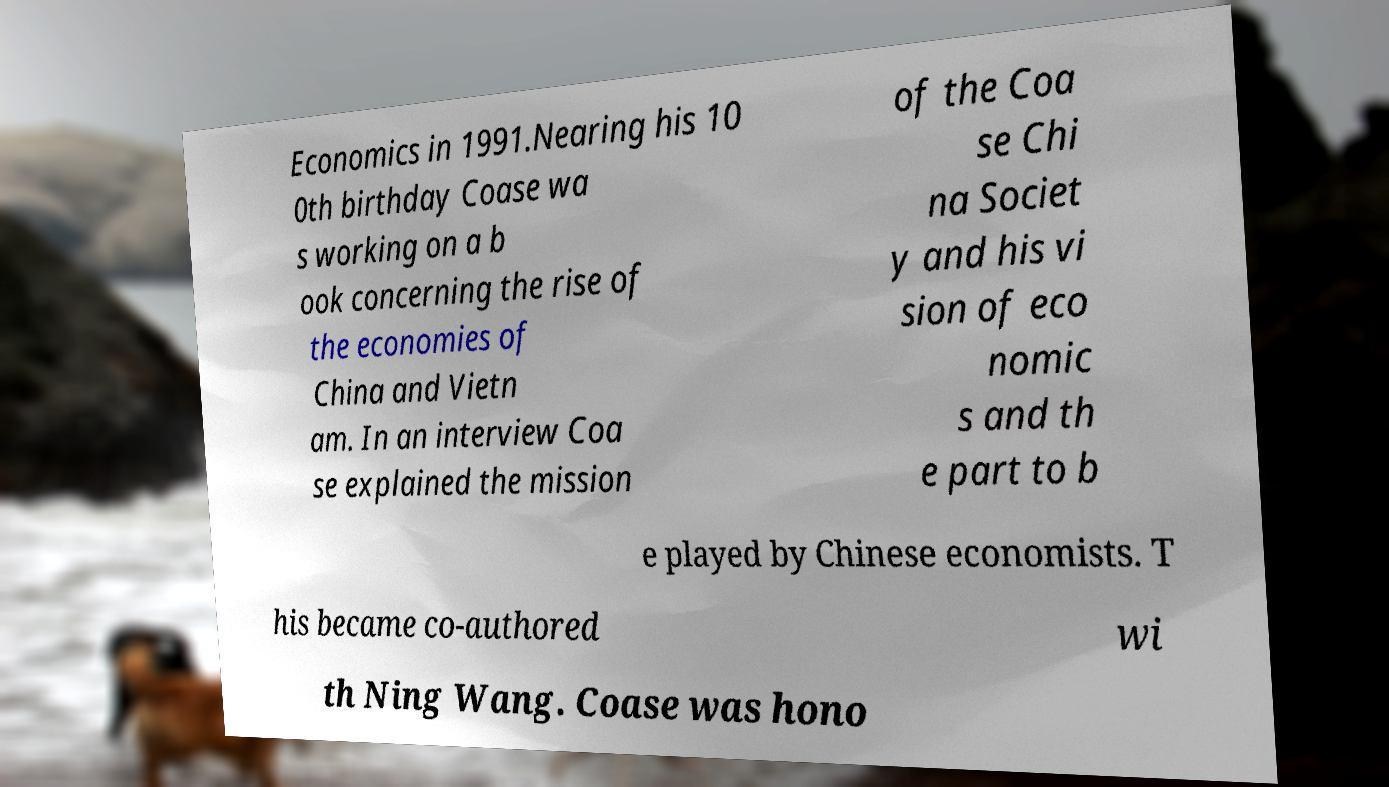Please identify and transcribe the text found in this image. Economics in 1991.Nearing his 10 0th birthday Coase wa s working on a b ook concerning the rise of the economies of China and Vietn am. In an interview Coa se explained the mission of the Coa se Chi na Societ y and his vi sion of eco nomic s and th e part to b e played by Chinese economists. T his became co-authored wi th Ning Wang. Coase was hono 